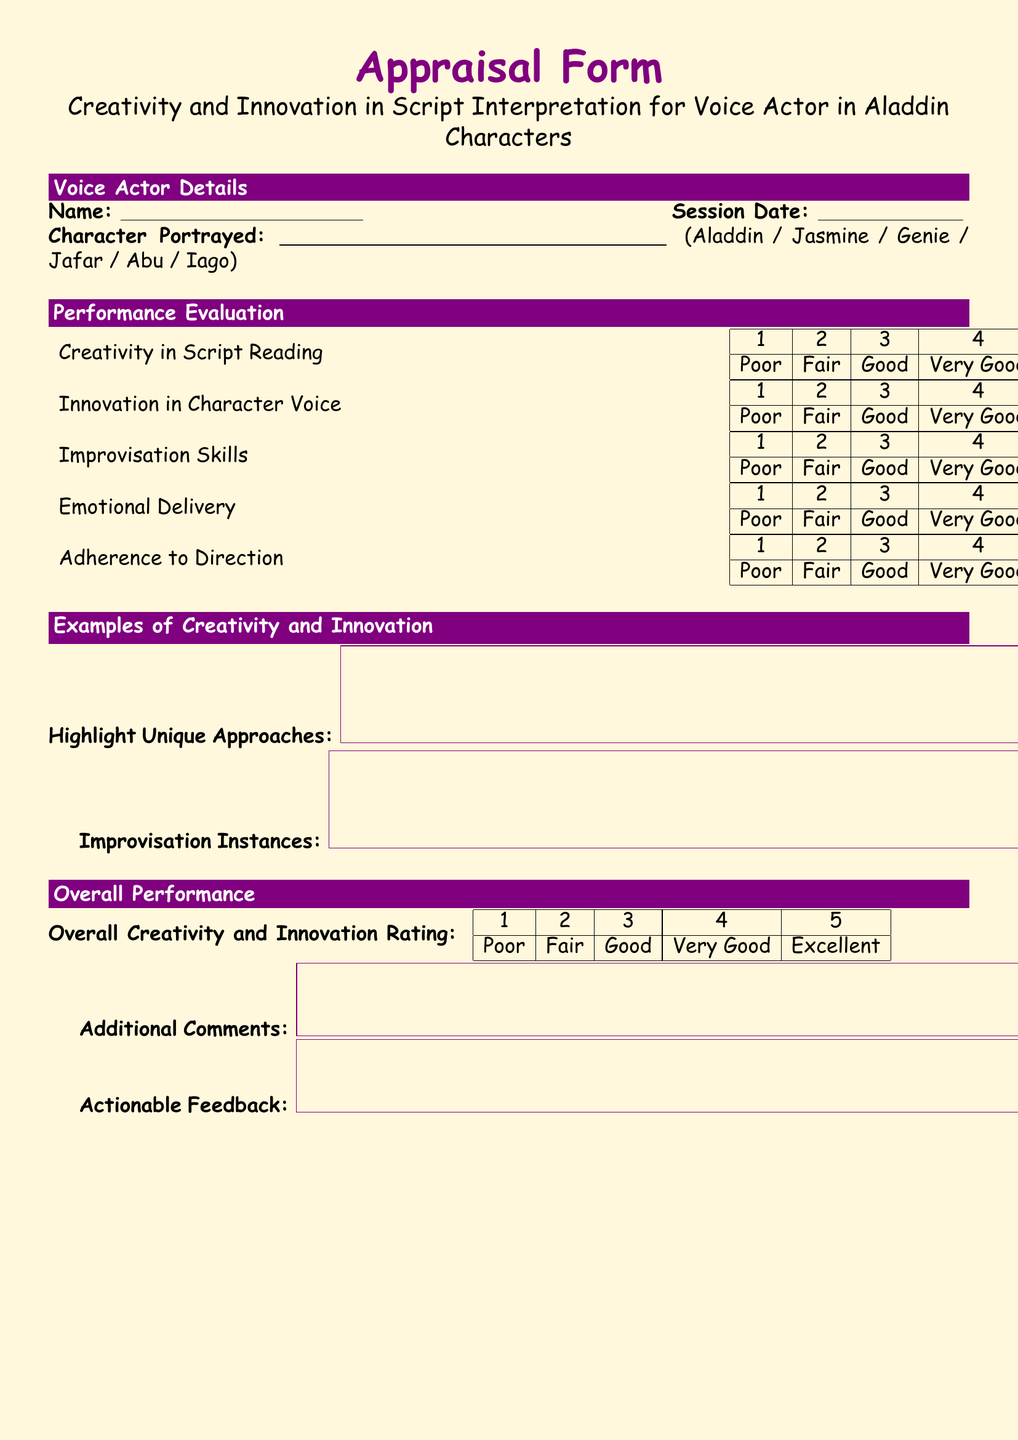What is the main title of the document? The main title is prominently displayed at the top of the document, stating its purpose and content.
Answer: Appraisal Form What is the session date field for? The session date field is for indicating the specific date of the recording session, providing context for the evaluation.
Answer: Session Date How many performance evaluation categories are listed? The categories reflect different areas of the voice actor's performance that are evaluated in the appraisal.
Answer: Five What character is not listed in the character portrayed options? The options provided allow the evaluator to select the character the voice actor portrayed, thus highlighting omission in the choices.
Answer: None What is the color theme used in the document? The color theme enhances the visual appeal and organization of the document, making it more engaging.
Answer: Magic purple and sandbg Which skill is included as part of the performance evaluation? The skills listed show what specific abilities are being assessed during the appraisal of the voice actor's performance.
Answer: Improvisation Skills What type of feedback is requested in the document? The feedback section aims to promote constructive suggestions and insights to encourage future performance improvement.
Answer: Actionable Feedback What rating scale is used in the performance evaluation? The rating scale provides a structured method for evaluators to assess the various aspects of the voice actor's performance.
Answer: 1 to 5 What is the overall performance rating category called? This designation summarizes the evaluator's perception of the voice actor's overall creativity and innovation in performance.
Answer: Overall Creativity and Innovation Rating 